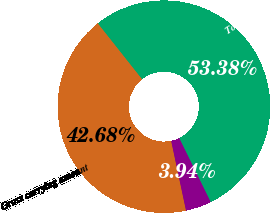Convert chart. <chart><loc_0><loc_0><loc_500><loc_500><pie_chart><fcel>Gross carrying amount<fcel>Accumulated amortization<fcel>Total identifiable intangible<nl><fcel>42.68%<fcel>3.94%<fcel>53.38%<nl></chart> 